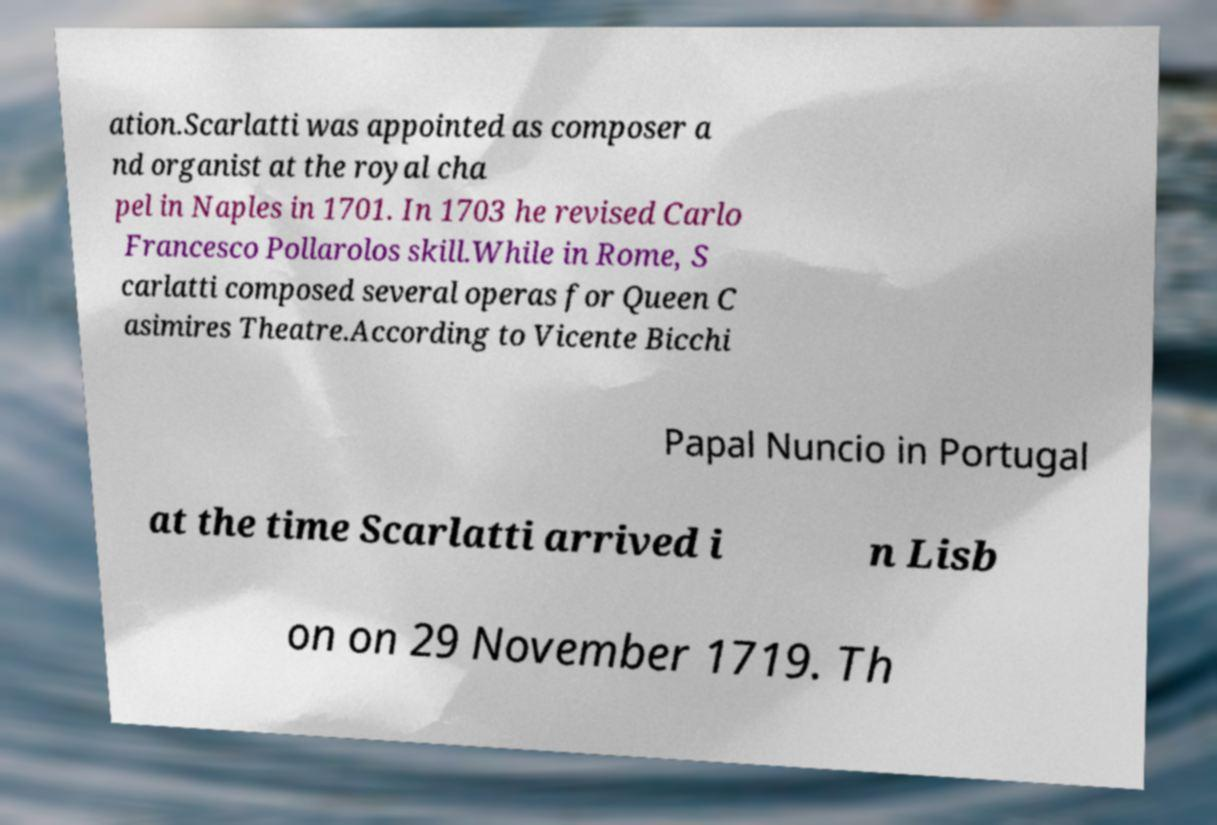What messages or text are displayed in this image? I need them in a readable, typed format. ation.Scarlatti was appointed as composer a nd organist at the royal cha pel in Naples in 1701. In 1703 he revised Carlo Francesco Pollarolos skill.While in Rome, S carlatti composed several operas for Queen C asimires Theatre.According to Vicente Bicchi Papal Nuncio in Portugal at the time Scarlatti arrived i n Lisb on on 29 November 1719. Th 